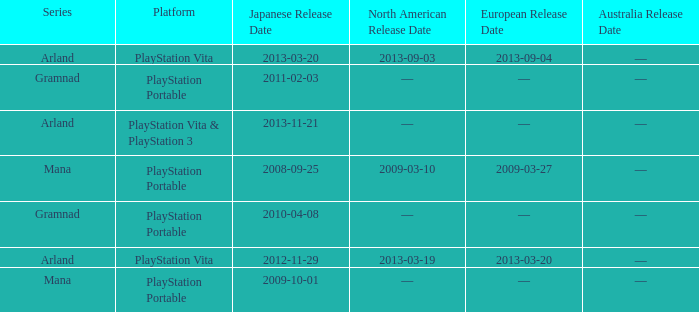What is the North American release date of the remake with a European release date on 2013-03-20? 2013-03-19. 